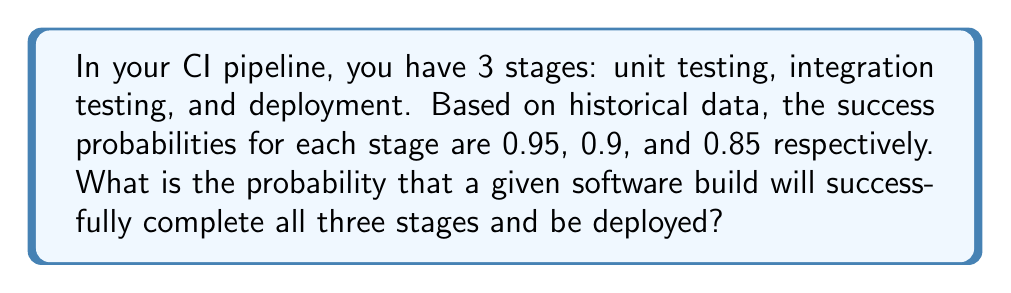Provide a solution to this math problem. To solve this problem, we need to follow these steps:

1. Understand that for a build to be successful, it must pass all three stages in sequence.
2. Recognize that this scenario represents independent events, where the success of one stage doesn't affect the others.
3. Apply the multiplication rule of probability for independent events.

Let's define our events:
$A$ = Success in unit testing (probability = 0.95)
$B$ = Success in integration testing (probability = 0.9)
$C$ = Success in deployment (probability = 0.85)

We want to find $P(A \cap B \cap C)$, the probability of all three events occurring.

For independent events, we multiply their individual probabilities:

$$P(A \cap B \cap C) = P(A) \times P(B) \times P(C)$$

Substituting the given probabilities:

$$P(A \cap B \cap C) = 0.95 \times 0.9 \times 0.85$$

Calculating:

$$P(A \cap B \cap C) = 0.72675$$

Therefore, the probability of a successful build completing all three stages is approximately 0.7268 or 72.68%.
Answer: 0.7268 